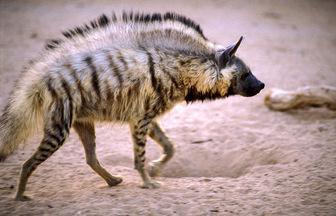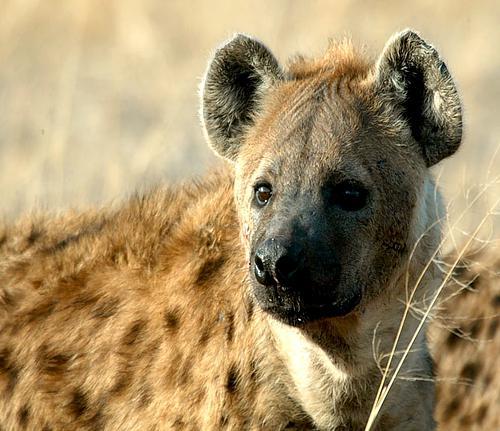The first image is the image on the left, the second image is the image on the right. Examine the images to the left and right. Is the description "There is a single hyena in each of the images." accurate? Answer yes or no. Yes. The first image is the image on the left, the second image is the image on the right. Analyze the images presented: Is the assertion "One image shows a dog-like animal walking with its body and head in profile and its hindquarters sloped lower than its shoulders." valid? Answer yes or no. Yes. 